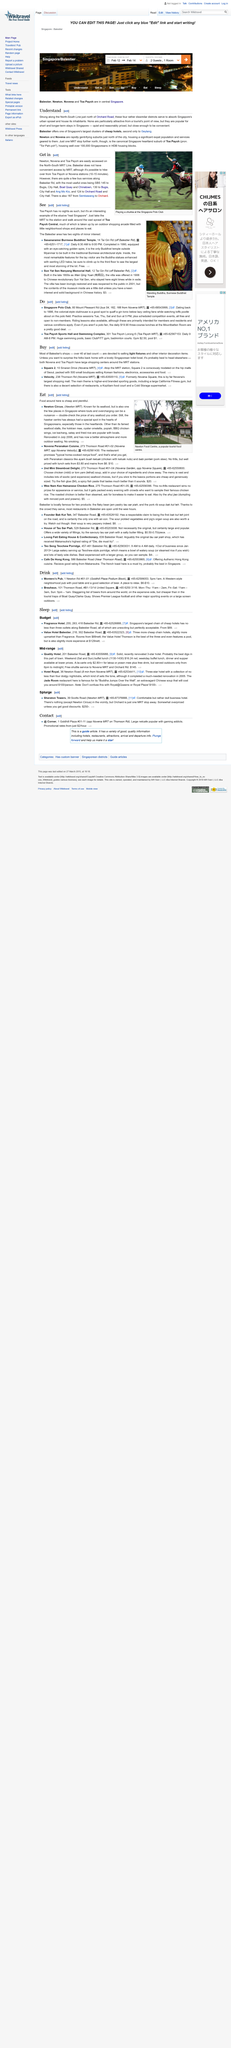Point out several critical features in this image. Newton, Novena, and Toa Payoh are locations that are easily accessible on the North-South MRT Line. The suburbs of Newton and Novena are rapidly gentrifying and are located just north of the city. According to the article 'Get in,' Belestier does not have convenient access by MRT. The most useful bus lines along Belestier Road are SBS 145, 130, and 124. Balestier is one of the four districts located along the North-South Line in the region just north of Orchard Road. Yes, it is. 